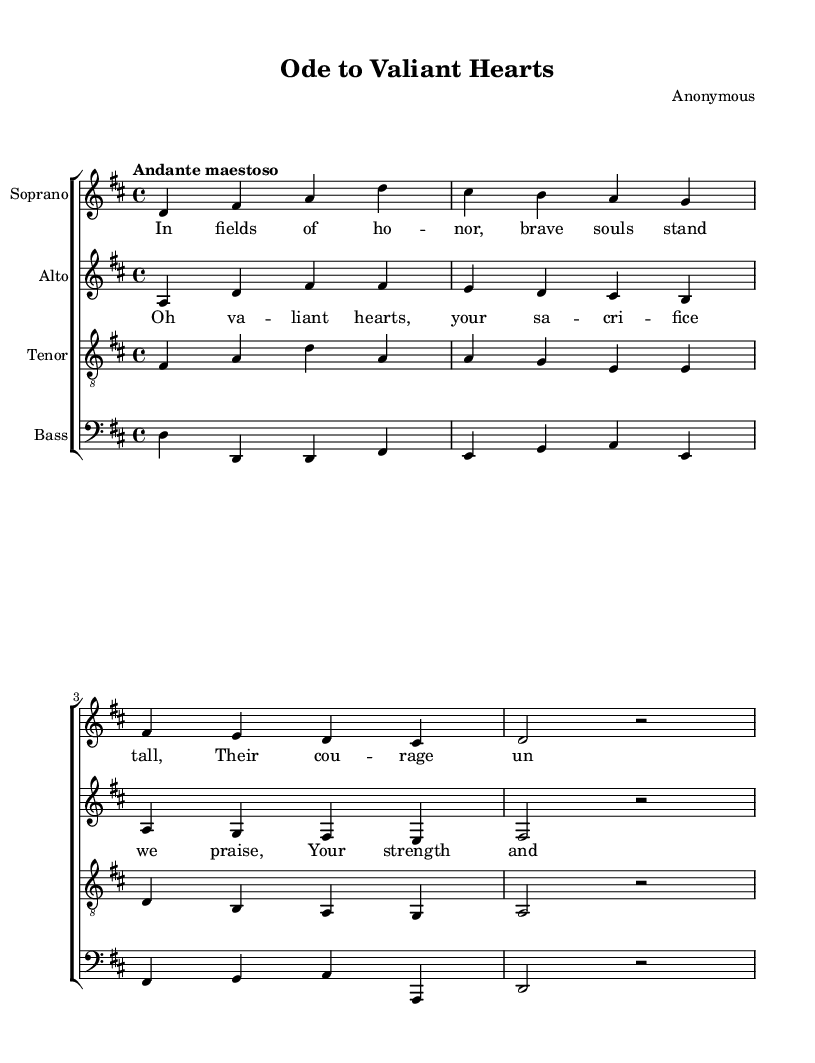What is the key signature of this music? The key signature is indicated by the sharp signs at the beginning of the staff line. In this case, there is a "C#" and "F#" in the key signature, indicating it is D major.
Answer: D major What is the time signature of this piece? The time signature is located at the beginning of the staff, which shows the organization of beats in each measure. Here it is indicated as 4/4.
Answer: 4/4 What is the tempo marking for the piece? The tempo marking, which provides guidance on the speed of the music, is given as "Andante maestoso" right before the first measure.
Answer: Andante maestoso How many voices are present in this choral work? The score has separate staves for each type of voice: Soprano, Alto, Tenor, and Bass. Therefore, there are four distinct voices.
Answer: Four What is the musical form of the work? The structure of the work consists of verses with a repeating chorus, which is characteristic of many choral compositions, especially in the Baroque style.
Answer: Verse and chorus Which lyric lines are sung by the soprano? By looking at the lyrics placed under the soprano staff, we can see that the first verse is sung by the soprano part, which starts with "In fields of honor, brave souls stand tall."
Answer: In fields of honor, brave souls stand tall What thematic elements are highlighted in this choral work? The lyrics emphasize themes of courage, sacrifice, and honor in the context of soldiers, a sentiment that is common in works celebrating valor, especially in the Baroque tradition.
Answer: Courage and sacrifice 